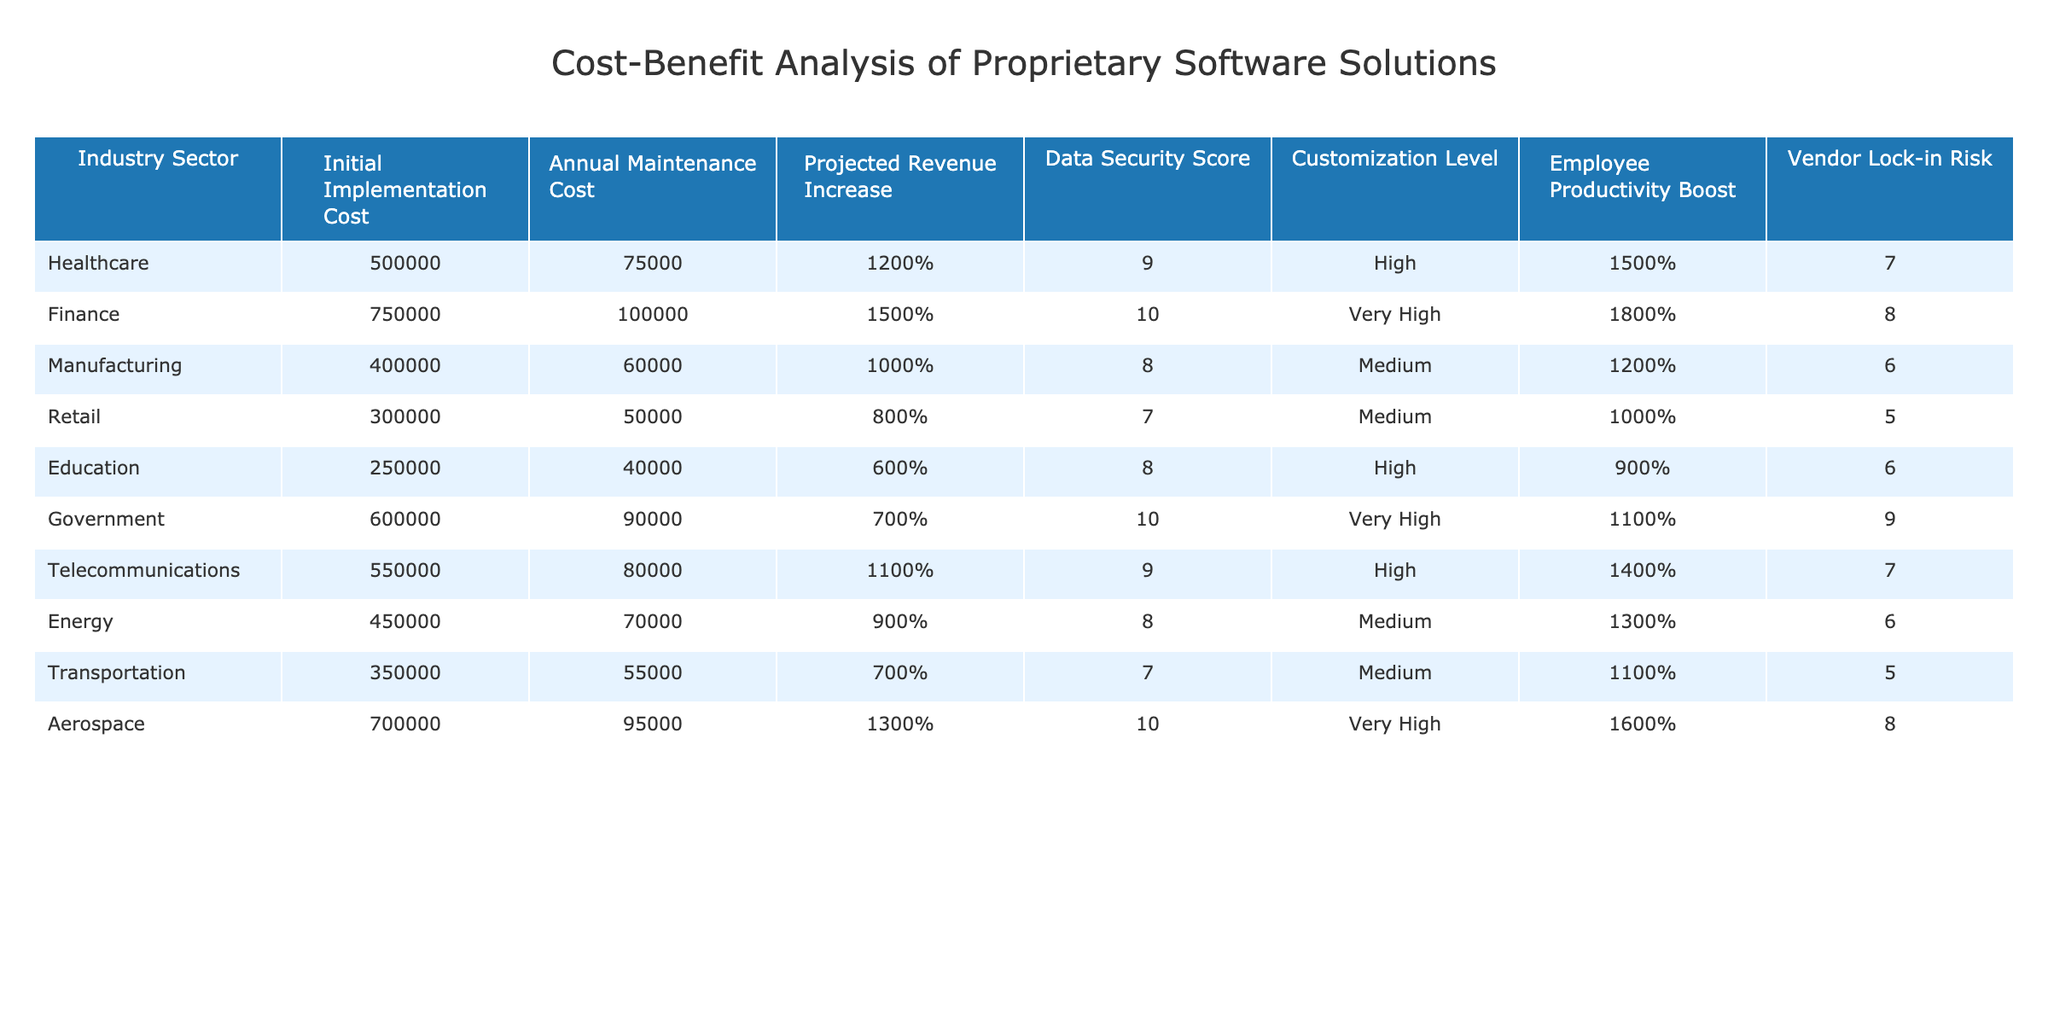What is the highest initial implementation cost among the industry sectors? The table shows the initial implementation costs for each industry sector, with Finance listed at $750,000, which is higher than all other sectors.
Answer: $750,000 Which industry sector has the lowest annual maintenance cost? By scanning the table, Education has the lowest annual maintenance cost of $40,000.
Answer: $40,000 What is the projected revenue increase for the Aerospace sector? The table indicates that the projected revenue increase for the Aerospace sector is 13%.
Answer: 13% Which sector has the highest data security score? According to the table, both Finance and Government sectors have the highest data security score of 10/10.
Answer: Finance and Government What is the average employee productivity boost across all industry sectors? Adding all the employee productivity boosts (15% + 18% + 12% + 10% + 9% + 11% + 14% + 13% + 11% + 16%) equals  15.7%, and dividing this by 10 gives an average of 14.5%.
Answer: 14.5% Is there a sector that has both high customization level and high data security score? Checking the table, Finance and Government have a very high data security score but no sector offers both high customization and high security scores simultaneously.
Answer: No What is the difference in initial implementation cost between Healthcare and Retail? The initial implementation cost for Healthcare is $500,000 and for Retail is $300,000. Subtracting these values gives $200,000.
Answer: $200,000 Which sector has the vendor lock-in risk rated highest? Looking at the table, the Finance sector has the highest vendor lock-in risk rated as 8/10.
Answer: Finance For which sector is the drawback of vendor lock-in risk the lowest? In the table, the Retail and Transportation sectors have the lowest vendor lock-in risks rated as 5/10.
Answer: Retail and Transportation What is the total projected revenue increase for the Healthcare and Manufacturing sectors combined? Adding the projected revenue increases of Healthcare (12%) and Manufacturing (10%) gives a total of 22%.
Answer: 22% 